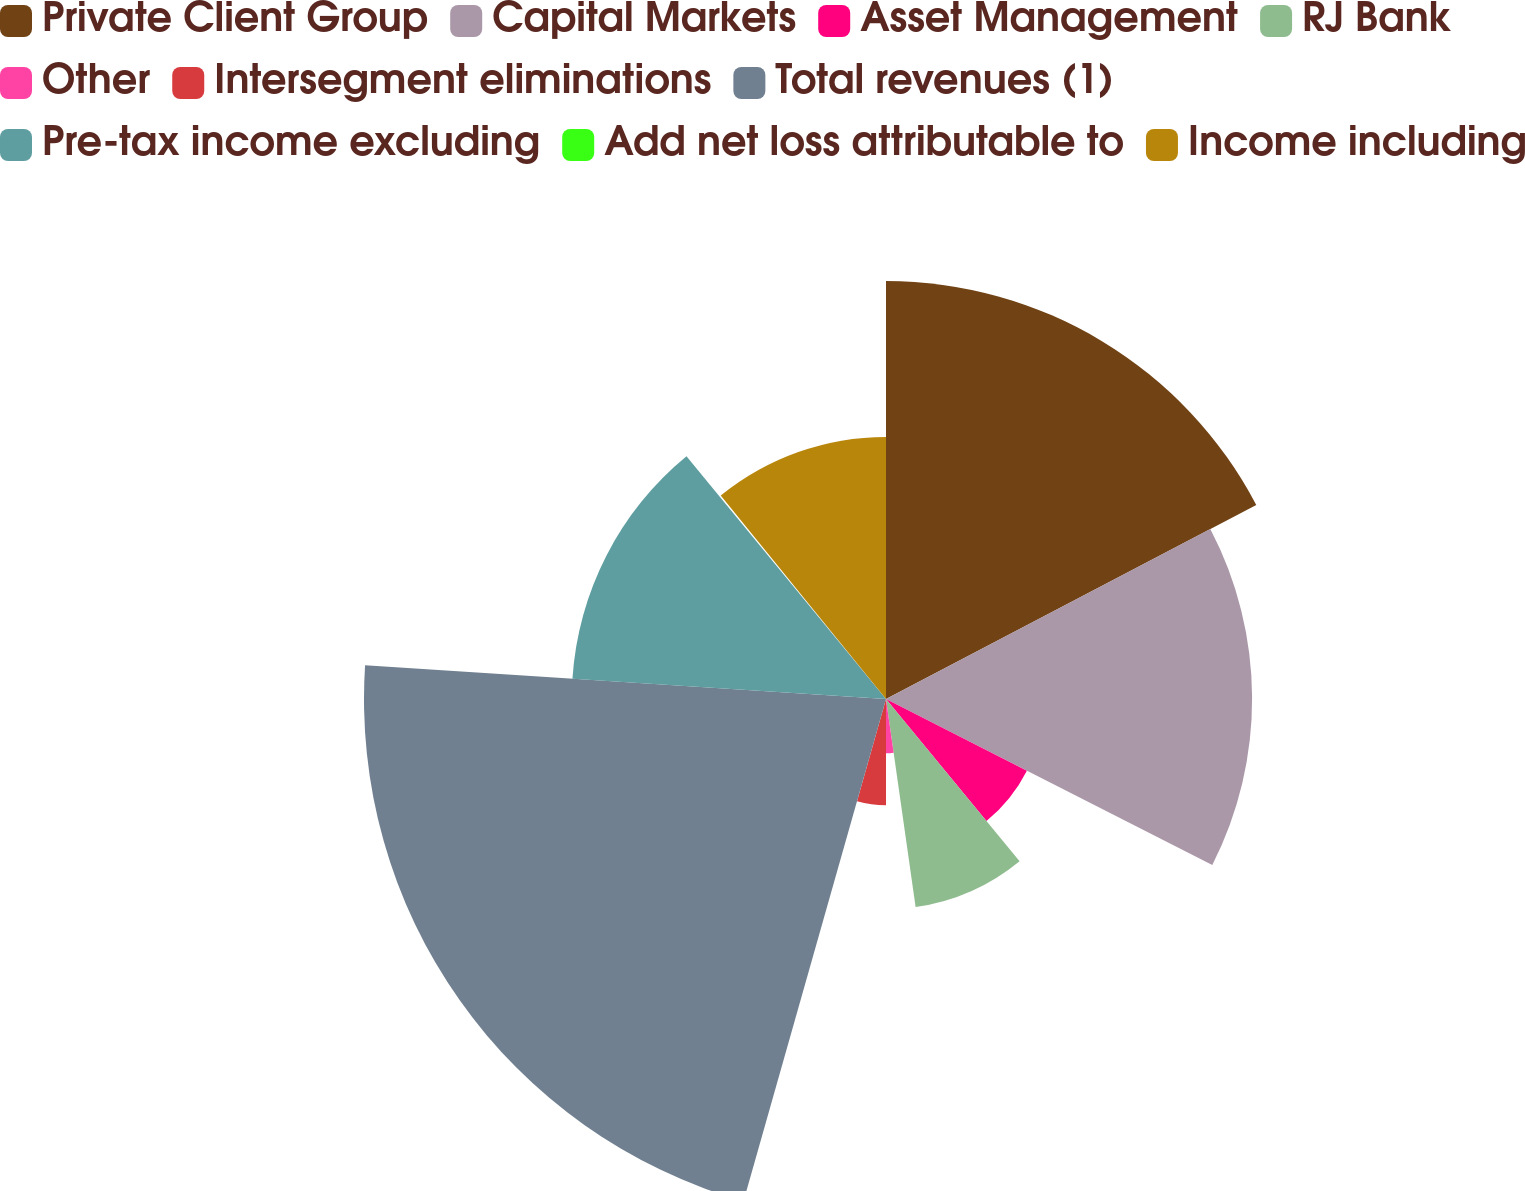Convert chart. <chart><loc_0><loc_0><loc_500><loc_500><pie_chart><fcel>Private Client Group<fcel>Capital Markets<fcel>Asset Management<fcel>RJ Bank<fcel>Other<fcel>Intersegment eliminations<fcel>Total revenues (1)<fcel>Pre-tax income excluding<fcel>Add net loss attributable to<fcel>Income including<nl><fcel>17.32%<fcel>15.17%<fcel>6.55%<fcel>8.71%<fcel>2.25%<fcel>4.4%<fcel>21.63%<fcel>13.02%<fcel>0.09%<fcel>10.86%<nl></chart> 